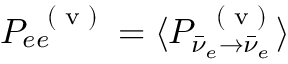Convert formula to latex. <formula><loc_0><loc_0><loc_500><loc_500>P _ { e e } ^ { ( v ) } = \langle P _ { \bar { \nu } _ { e } \to \bar { \nu } _ { e } } ^ { ( v ) } \rangle</formula> 